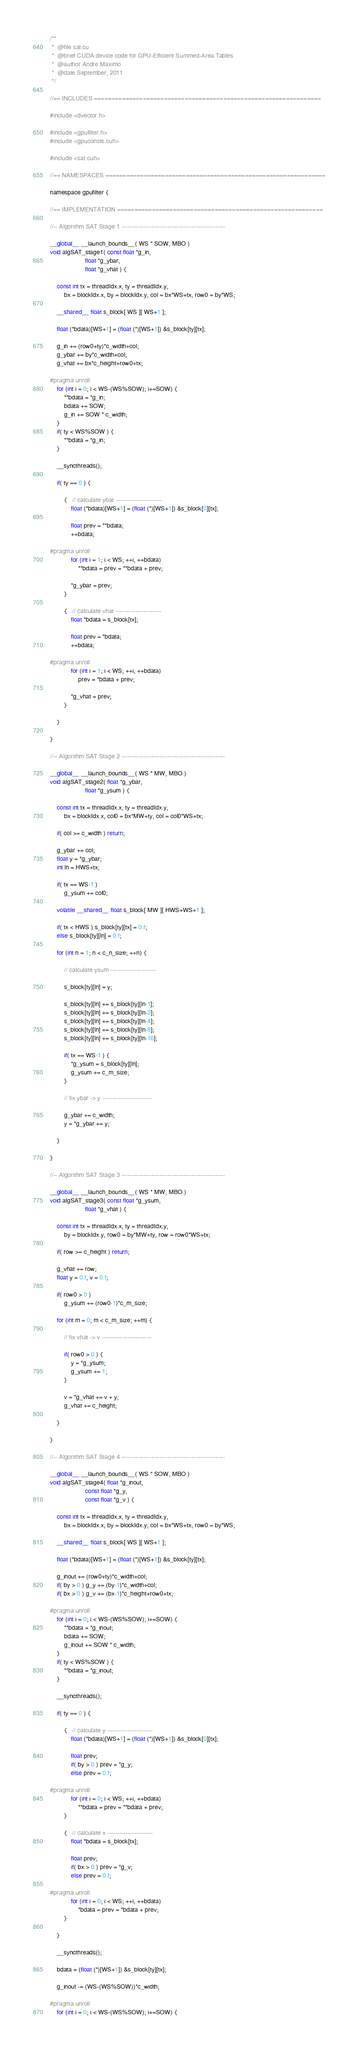<code> <loc_0><loc_0><loc_500><loc_500><_Cuda_>/**
 *  @file sat.cu
 *  @brief CUDA device code for GPU-Efficient Summed-Area Tables
 *  @author Andre Maximo
 *  @date September, 2011
 */

//== INCLUDES =================================================================

#include <dvector.h>

#include <gpufilter.h>
#include <gpuconsts.cuh>

#include <sat.cuh>

//== NAMESPACES ===============================================================

namespace gpufilter {

//== IMPLEMENTATION ===========================================================

//-- Algorithm SAT Stage 1 ----------------------------------------------------

__global__ __launch_bounds__( WS * SOW, MBO )
void algSAT_stage1( const float *g_in,
                    float *g_ybar,
                    float *g_vhat ) {

	const int tx = threadIdx.x, ty = threadIdx.y,
        bx = blockIdx.x, by = blockIdx.y, col = bx*WS+tx, row0 = by*WS;

	__shared__ float s_block[ WS ][ WS+1 ];

    float (*bdata)[WS+1] = (float (*)[WS+1]) &s_block[ty][tx];

	g_in += (row0+ty)*c_width+col;
	g_ybar += by*c_width+col;
	g_vhat += bx*c_height+row0+tx;

#pragma unroll
    for (int i = 0; i < WS-(WS%SOW); i+=SOW) {
        **bdata = *g_in;
        bdata += SOW;
        g_in += SOW * c_width;
    }
    if( ty < WS%SOW ) {
        **bdata = *g_in;
    }

	__syncthreads();

	if( ty == 0 ) {

        {   // calculate ybar -----------------------
            float (*bdata)[WS+1] = (float (*)[WS+1]) &s_block[0][tx];

            float prev = **bdata;
            ++bdata;

#pragma unroll
            for (int i = 1; i < WS; ++i, ++bdata)
                **bdata = prev = **bdata + prev;

            *g_ybar = prev;
        }

        {   // calculate vhat -----------------------
            float *bdata = s_block[tx];

            float prev = *bdata;
            ++bdata;

#pragma unroll
            for (int i = 1; i < WS; ++i, ++bdata)
                prev = *bdata + prev;

            *g_vhat = prev;
        }

	}

}

//-- Algorithm SAT Stage 2 ----------------------------------------------------

__global__ __launch_bounds__( WS * MW, MBO )
void algSAT_stage2( float *g_ybar,
                    float *g_ysum ) {

	const int tx = threadIdx.x, ty = threadIdx.y,
        bx = blockIdx.x, col0 = bx*MW+ty, col = col0*WS+tx;

	if( col >= c_width ) return;

	g_ybar += col;
	float y = *g_ybar;
	int ln = HWS+tx;

	if( tx == WS-1 )
		g_ysum += col0;

	volatile __shared__ float s_block[ MW ][ HWS+WS+1 ];

	if( tx < HWS ) s_block[ty][tx] = 0.f;
	else s_block[ty][ln] = 0.f;

	for (int n = 1; n < c_n_size; ++n) {

        // calculate ysum -----------------------

		s_block[ty][ln] = y;

		s_block[ty][ln] += s_block[ty][ln-1];
		s_block[ty][ln] += s_block[ty][ln-2];
		s_block[ty][ln] += s_block[ty][ln-4];
		s_block[ty][ln] += s_block[ty][ln-8];
		s_block[ty][ln] += s_block[ty][ln-16];

		if( tx == WS-1 ) {
			*g_ysum = s_block[ty][ln];
			g_ysum += c_m_size;
		}

        // fix ybar -> y -------------------------

		g_ybar += c_width;
		y = *g_ybar += y;

	}

}

//-- Algorithm SAT Stage 3 ----------------------------------------------------

__global__ __launch_bounds__( WS * MW, MBO )
void algSAT_stage3( const float *g_ysum,
                    float *g_vhat ) {

	const int tx = threadIdx.x, ty = threadIdx.y,
        by = blockIdx.y, row0 = by*MW+ty, row = row0*WS+tx;

	if( row >= c_height ) return;

	g_vhat += row;
	float y = 0.f, v = 0.f;

	if( row0 > 0 )
		g_ysum += (row0-1)*c_m_size;

	for (int m = 0; m < c_m_size; ++m) {

        // fix vhat -> v -------------------------

		if( row0 > 0 ) {
			y = *g_ysum;
			g_ysum += 1;
		}

		v = *g_vhat += v + y;
		g_vhat += c_height;

	}

}

//-- Algorithm SAT Stage 4 ----------------------------------------------------

__global__ __launch_bounds__( WS * SOW, MBO )
void algSAT_stage4( float *g_inout,
                    const float *g_y,
                    const float *g_v ) {

	const int tx = threadIdx.x, ty = threadIdx.y,
        bx = blockIdx.x, by = blockIdx.y, col = bx*WS+tx, row0 = by*WS;

	__shared__ float s_block[ WS ][ WS+1 ];

    float (*bdata)[WS+1] = (float (*)[WS+1]) &s_block[ty][tx];

	g_inout += (row0+ty)*c_width+col;
	if( by > 0 ) g_y += (by-1)*c_width+col;
	if( bx > 0 ) g_v += (bx-1)*c_height+row0+tx;

#pragma unroll
    for (int i = 0; i < WS-(WS%SOW); i+=SOW) {
        **bdata = *g_inout;
        bdata += SOW;
        g_inout += SOW * c_width;
    }
    if( ty < WS%SOW ) {
        **bdata = *g_inout;
    }

	__syncthreads();

	if( ty == 0 ) {

        {   // calculate y -----------------------
            float (*bdata)[WS+1] = (float (*)[WS+1]) &s_block[0][tx];

            float prev;
            if( by > 0 ) prev = *g_y;
            else prev = 0.f;

#pragma unroll
            for (int i = 0; i < WS; ++i, ++bdata)
                **bdata = prev = **bdata + prev;
        }

        {   // calculate x -----------------------
            float *bdata = s_block[tx];

            float prev;
            if( bx > 0 ) prev = *g_v;
            else prev = 0.f;

#pragma unroll
            for (int i = 0; i < WS; ++i, ++bdata)
                *bdata = prev = *bdata + prev;
        }

	}

	__syncthreads();

    bdata = (float (*)[WS+1]) &s_block[ty][tx];

	g_inout -= (WS-(WS%SOW))*c_width;

#pragma unroll
    for (int i = 0; i < WS-(WS%SOW); i+=SOW) {</code> 